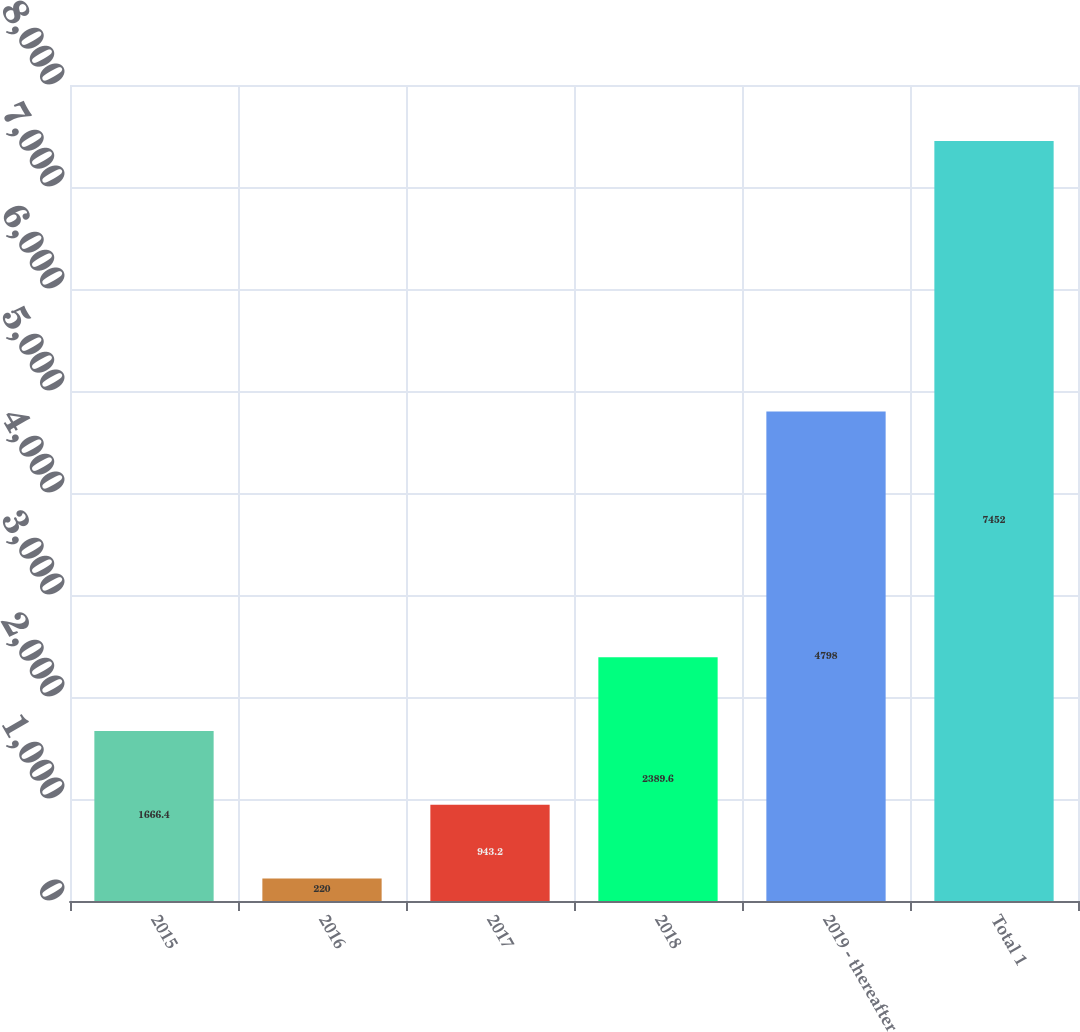Convert chart to OTSL. <chart><loc_0><loc_0><loc_500><loc_500><bar_chart><fcel>2015<fcel>2016<fcel>2017<fcel>2018<fcel>2019 - thereafter<fcel>Total 1<nl><fcel>1666.4<fcel>220<fcel>943.2<fcel>2389.6<fcel>4798<fcel>7452<nl></chart> 